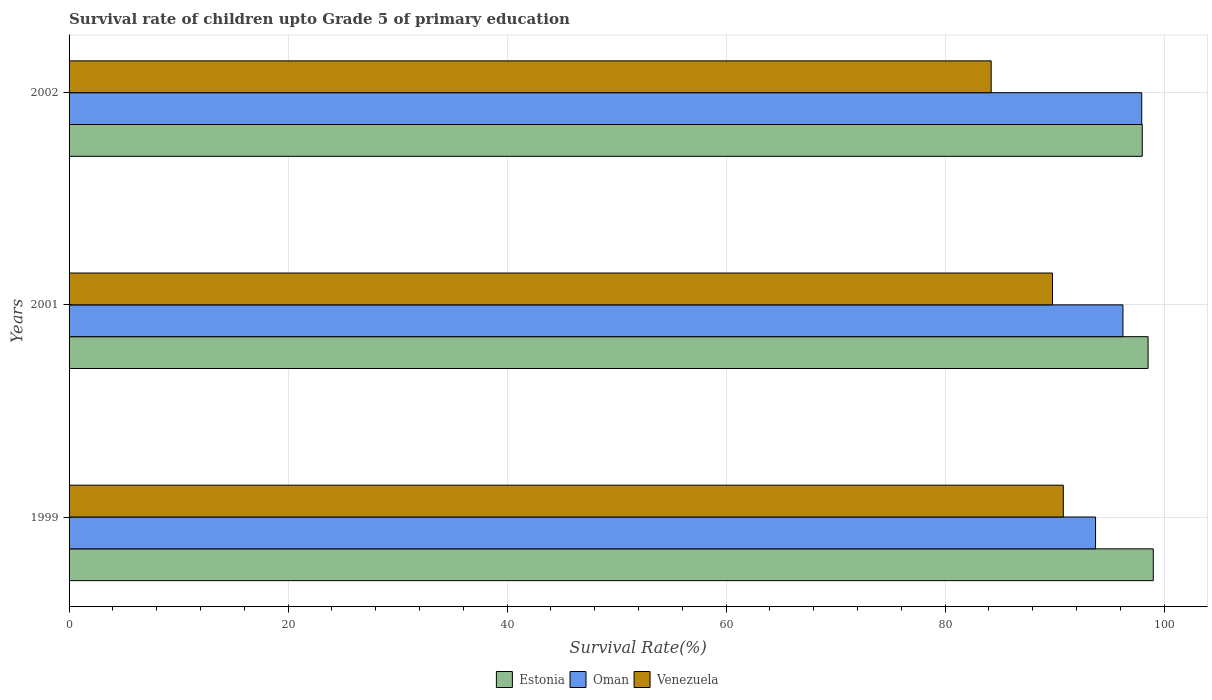How many different coloured bars are there?
Your answer should be compact. 3. How many groups of bars are there?
Keep it short and to the point. 3. Are the number of bars per tick equal to the number of legend labels?
Give a very brief answer. Yes. How many bars are there on the 3rd tick from the top?
Your response must be concise. 3. How many bars are there on the 3rd tick from the bottom?
Provide a short and direct response. 3. What is the label of the 3rd group of bars from the top?
Your response must be concise. 1999. What is the survival rate of children in Estonia in 1999?
Give a very brief answer. 99.01. Across all years, what is the maximum survival rate of children in Estonia?
Your answer should be very brief. 99.01. Across all years, what is the minimum survival rate of children in Estonia?
Ensure brevity in your answer.  98.01. What is the total survival rate of children in Estonia in the graph?
Keep it short and to the point. 295.55. What is the difference between the survival rate of children in Estonia in 2001 and that in 2002?
Keep it short and to the point. 0.53. What is the difference between the survival rate of children in Estonia in 1999 and the survival rate of children in Oman in 2002?
Provide a short and direct response. 1.05. What is the average survival rate of children in Estonia per year?
Offer a very short reply. 98.52. In the year 2002, what is the difference between the survival rate of children in Oman and survival rate of children in Venezuela?
Offer a very short reply. 13.75. In how many years, is the survival rate of children in Oman greater than 32 %?
Your answer should be compact. 3. What is the ratio of the survival rate of children in Estonia in 2001 to that in 2002?
Your response must be concise. 1.01. What is the difference between the highest and the second highest survival rate of children in Oman?
Provide a short and direct response. 1.71. What is the difference between the highest and the lowest survival rate of children in Oman?
Make the answer very short. 4.22. Is the sum of the survival rate of children in Venezuela in 1999 and 2002 greater than the maximum survival rate of children in Oman across all years?
Keep it short and to the point. Yes. What does the 3rd bar from the top in 2002 represents?
Give a very brief answer. Estonia. What does the 3rd bar from the bottom in 2002 represents?
Offer a terse response. Venezuela. Is it the case that in every year, the sum of the survival rate of children in Venezuela and survival rate of children in Estonia is greater than the survival rate of children in Oman?
Provide a short and direct response. Yes. Are all the bars in the graph horizontal?
Give a very brief answer. Yes. How many years are there in the graph?
Keep it short and to the point. 3. What is the difference between two consecutive major ticks on the X-axis?
Ensure brevity in your answer.  20. Does the graph contain any zero values?
Your answer should be very brief. No. Does the graph contain grids?
Ensure brevity in your answer.  Yes. Where does the legend appear in the graph?
Ensure brevity in your answer.  Bottom center. How many legend labels are there?
Provide a succinct answer. 3. How are the legend labels stacked?
Offer a very short reply. Horizontal. What is the title of the graph?
Your answer should be compact. Survival rate of children upto Grade 5 of primary education. Does "Timor-Leste" appear as one of the legend labels in the graph?
Your response must be concise. No. What is the label or title of the X-axis?
Give a very brief answer. Survival Rate(%). What is the Survival Rate(%) in Estonia in 1999?
Provide a succinct answer. 99.01. What is the Survival Rate(%) in Oman in 1999?
Your response must be concise. 93.74. What is the Survival Rate(%) in Venezuela in 1999?
Provide a succinct answer. 90.8. What is the Survival Rate(%) of Estonia in 2001?
Your response must be concise. 98.54. What is the Survival Rate(%) of Oman in 2001?
Ensure brevity in your answer.  96.24. What is the Survival Rate(%) in Venezuela in 2001?
Offer a very short reply. 89.81. What is the Survival Rate(%) of Estonia in 2002?
Give a very brief answer. 98.01. What is the Survival Rate(%) of Oman in 2002?
Offer a very short reply. 97.96. What is the Survival Rate(%) in Venezuela in 2002?
Your answer should be compact. 84.21. Across all years, what is the maximum Survival Rate(%) in Estonia?
Ensure brevity in your answer.  99.01. Across all years, what is the maximum Survival Rate(%) in Oman?
Your answer should be very brief. 97.96. Across all years, what is the maximum Survival Rate(%) of Venezuela?
Offer a very short reply. 90.8. Across all years, what is the minimum Survival Rate(%) in Estonia?
Give a very brief answer. 98.01. Across all years, what is the minimum Survival Rate(%) of Oman?
Provide a succinct answer. 93.74. Across all years, what is the minimum Survival Rate(%) of Venezuela?
Keep it short and to the point. 84.21. What is the total Survival Rate(%) in Estonia in the graph?
Your answer should be very brief. 295.55. What is the total Survival Rate(%) of Oman in the graph?
Give a very brief answer. 287.94. What is the total Survival Rate(%) of Venezuela in the graph?
Provide a short and direct response. 264.81. What is the difference between the Survival Rate(%) of Estonia in 1999 and that in 2001?
Provide a short and direct response. 0.48. What is the difference between the Survival Rate(%) in Oman in 1999 and that in 2001?
Keep it short and to the point. -2.5. What is the difference between the Survival Rate(%) in Venezuela in 1999 and that in 2001?
Your answer should be compact. 0.99. What is the difference between the Survival Rate(%) in Estonia in 1999 and that in 2002?
Make the answer very short. 1.01. What is the difference between the Survival Rate(%) of Oman in 1999 and that in 2002?
Your answer should be compact. -4.22. What is the difference between the Survival Rate(%) in Venezuela in 1999 and that in 2002?
Make the answer very short. 6.59. What is the difference between the Survival Rate(%) in Estonia in 2001 and that in 2002?
Provide a succinct answer. 0.53. What is the difference between the Survival Rate(%) of Oman in 2001 and that in 2002?
Keep it short and to the point. -1.71. What is the difference between the Survival Rate(%) of Venezuela in 2001 and that in 2002?
Your answer should be compact. 5.6. What is the difference between the Survival Rate(%) of Estonia in 1999 and the Survival Rate(%) of Oman in 2001?
Provide a succinct answer. 2.77. What is the difference between the Survival Rate(%) of Estonia in 1999 and the Survival Rate(%) of Venezuela in 2001?
Your answer should be very brief. 9.2. What is the difference between the Survival Rate(%) in Oman in 1999 and the Survival Rate(%) in Venezuela in 2001?
Offer a very short reply. 3.93. What is the difference between the Survival Rate(%) in Estonia in 1999 and the Survival Rate(%) in Oman in 2002?
Keep it short and to the point. 1.05. What is the difference between the Survival Rate(%) of Estonia in 1999 and the Survival Rate(%) of Venezuela in 2002?
Your response must be concise. 14.8. What is the difference between the Survival Rate(%) of Oman in 1999 and the Survival Rate(%) of Venezuela in 2002?
Give a very brief answer. 9.53. What is the difference between the Survival Rate(%) of Estonia in 2001 and the Survival Rate(%) of Oman in 2002?
Your response must be concise. 0.58. What is the difference between the Survival Rate(%) in Estonia in 2001 and the Survival Rate(%) in Venezuela in 2002?
Offer a terse response. 14.33. What is the difference between the Survival Rate(%) in Oman in 2001 and the Survival Rate(%) in Venezuela in 2002?
Keep it short and to the point. 12.04. What is the average Survival Rate(%) in Estonia per year?
Keep it short and to the point. 98.52. What is the average Survival Rate(%) of Oman per year?
Provide a short and direct response. 95.98. What is the average Survival Rate(%) of Venezuela per year?
Offer a terse response. 88.27. In the year 1999, what is the difference between the Survival Rate(%) in Estonia and Survival Rate(%) in Oman?
Your answer should be very brief. 5.27. In the year 1999, what is the difference between the Survival Rate(%) in Estonia and Survival Rate(%) in Venezuela?
Your answer should be compact. 8.22. In the year 1999, what is the difference between the Survival Rate(%) in Oman and Survival Rate(%) in Venezuela?
Provide a succinct answer. 2.94. In the year 2001, what is the difference between the Survival Rate(%) of Estonia and Survival Rate(%) of Oman?
Make the answer very short. 2.29. In the year 2001, what is the difference between the Survival Rate(%) in Estonia and Survival Rate(%) in Venezuela?
Make the answer very short. 8.73. In the year 2001, what is the difference between the Survival Rate(%) of Oman and Survival Rate(%) of Venezuela?
Offer a terse response. 6.43. In the year 2002, what is the difference between the Survival Rate(%) of Estonia and Survival Rate(%) of Oman?
Keep it short and to the point. 0.05. In the year 2002, what is the difference between the Survival Rate(%) in Estonia and Survival Rate(%) in Venezuela?
Offer a very short reply. 13.8. In the year 2002, what is the difference between the Survival Rate(%) of Oman and Survival Rate(%) of Venezuela?
Your answer should be very brief. 13.75. What is the ratio of the Survival Rate(%) of Oman in 1999 to that in 2001?
Your answer should be very brief. 0.97. What is the ratio of the Survival Rate(%) of Venezuela in 1999 to that in 2001?
Give a very brief answer. 1.01. What is the ratio of the Survival Rate(%) of Estonia in 1999 to that in 2002?
Offer a very short reply. 1.01. What is the ratio of the Survival Rate(%) of Oman in 1999 to that in 2002?
Ensure brevity in your answer.  0.96. What is the ratio of the Survival Rate(%) in Venezuela in 1999 to that in 2002?
Your response must be concise. 1.08. What is the ratio of the Survival Rate(%) in Estonia in 2001 to that in 2002?
Provide a short and direct response. 1.01. What is the ratio of the Survival Rate(%) of Oman in 2001 to that in 2002?
Give a very brief answer. 0.98. What is the ratio of the Survival Rate(%) of Venezuela in 2001 to that in 2002?
Your answer should be very brief. 1.07. What is the difference between the highest and the second highest Survival Rate(%) in Estonia?
Make the answer very short. 0.48. What is the difference between the highest and the second highest Survival Rate(%) in Oman?
Offer a very short reply. 1.71. What is the difference between the highest and the lowest Survival Rate(%) of Estonia?
Give a very brief answer. 1.01. What is the difference between the highest and the lowest Survival Rate(%) in Oman?
Provide a short and direct response. 4.22. What is the difference between the highest and the lowest Survival Rate(%) of Venezuela?
Make the answer very short. 6.59. 